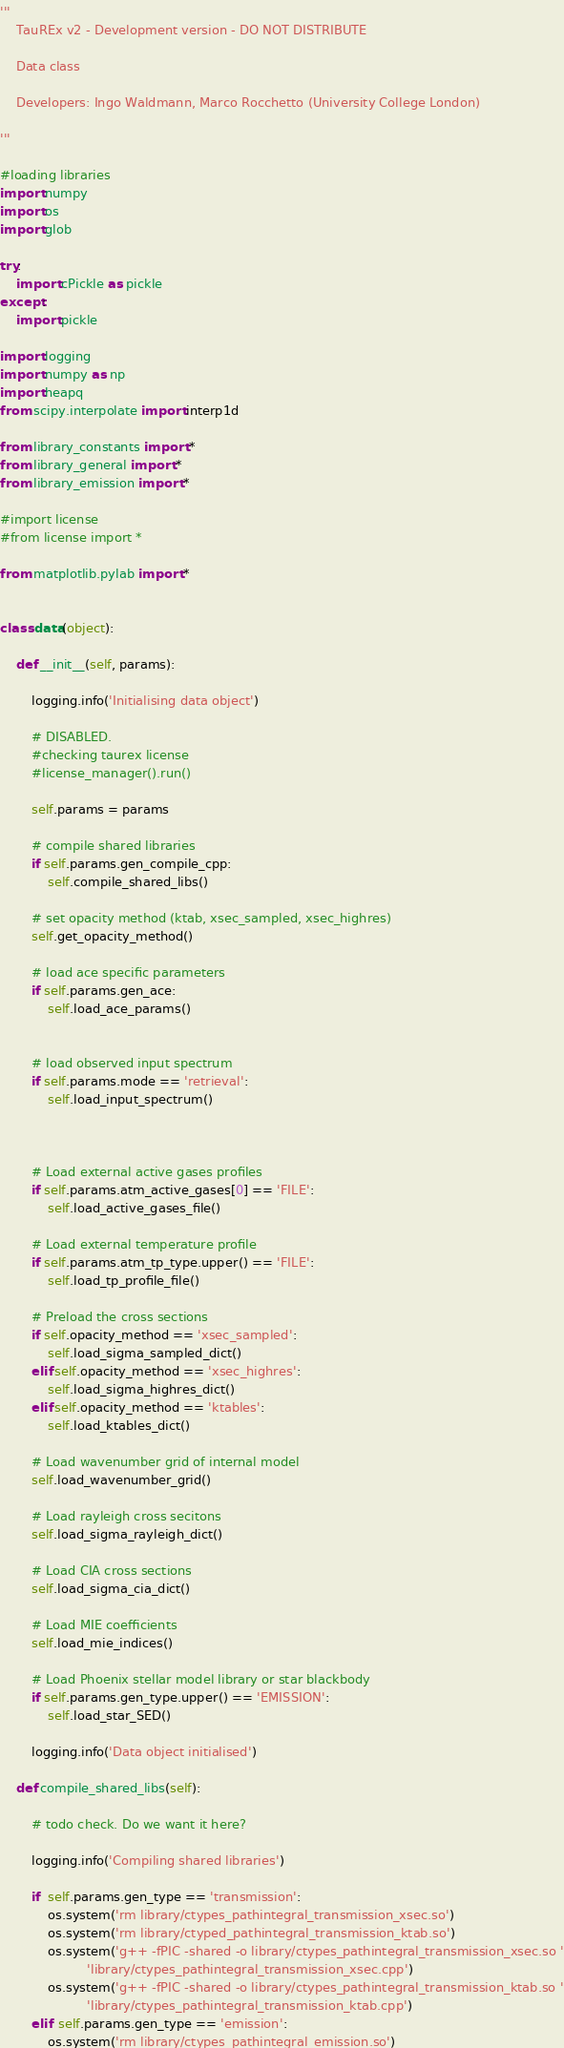Convert code to text. <code><loc_0><loc_0><loc_500><loc_500><_Python_>'''
    TauREx v2 - Development version - DO NOT DISTRIBUTE

    Data class

    Developers: Ingo Waldmann, Marco Rocchetto (University College London)

'''

#loading libraries     
import numpy
import os
import glob

try:
    import cPickle as pickle
except:
    import pickle

import logging
import numpy as np
import heapq
from scipy.interpolate import interp1d

from library_constants import *
from library_general import *
from library_emission import *

#import license
#from license import *

from matplotlib.pylab import *


class data(object):

    def __init__(self, params):

        logging.info('Initialising data object')

        # DISABLED.
        #checking taurex license
        #license_manager().run()
        
        self.params = params

        # compile shared libraries
        if self.params.gen_compile_cpp:
            self.compile_shared_libs()

        # set opacity method (ktab, xsec_sampled, xsec_highres)
        self.get_opacity_method()

        # load ace specific parameters
        if self.params.gen_ace:
            self.load_ace_params()


        # load observed input spectrum
        if self.params.mode == 'retrieval':
            self.load_input_spectrum()



        # Load external active gases profiles
        if self.params.atm_active_gases[0] == 'FILE':
            self.load_active_gases_file()

        # Load external temperature profile
        if self.params.atm_tp_type.upper() == 'FILE':
            self.load_tp_profile_file()

        # Preload the cross sections
        if self.opacity_method == 'xsec_sampled':
            self.load_sigma_sampled_dict()
        elif self.opacity_method == 'xsec_highres':
            self.load_sigma_highres_dict()
        elif self.opacity_method == 'ktables':
            self.load_ktables_dict()

        # Load wavenumber grid of internal model
        self.load_wavenumber_grid()

        # Load rayleigh cross secitons
        self.load_sigma_rayleigh_dict()

        # Load CIA cross sections
        self.load_sigma_cia_dict()
        
        # Load MIE coefficients 
        self.load_mie_indices()

        # Load Phoenix stellar model library or star blackbody
        if self.params.gen_type.upper() == 'EMISSION':
            self.load_star_SED()

        logging.info('Data object initialised')

    def compile_shared_libs(self):

        # todo check. Do we want it here?

        logging.info('Compiling shared libraries')

        if  self.params.gen_type == 'transmission':
            os.system('rm library/ctypes_pathintegral_transmission_xsec.so')
            os.system('rm library/ctyped_pathintegral_transmission_ktab.so')
            os.system('g++ -fPIC -shared -o library/ctypes_pathintegral_transmission_xsec.so '
                      'library/ctypes_pathintegral_transmission_xsec.cpp')
            os.system('g++ -fPIC -shared -o library/ctypes_pathintegral_transmission_ktab.so '
                      'library/ctypes_pathintegral_transmission_ktab.cpp')
        elif  self.params.gen_type == 'emission':
            os.system('rm library/ctypes_pathintegral_emission.so')</code> 